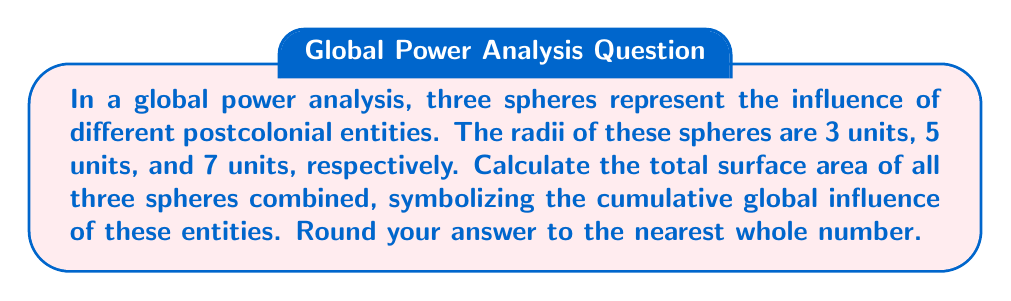Could you help me with this problem? To solve this problem, we'll follow these steps:

1) The formula for the surface area of a sphere is $A = 4\pi r^2$, where $r$ is the radius.

2) Let's calculate the surface area for each sphere:

   Sphere 1 (radius 3): $A_1 = 4\pi (3)^2 = 36\pi$
   Sphere 2 (radius 5): $A_2 = 4\pi (5)^2 = 100\pi$
   Sphere 3 (radius 7): $A_3 = 4\pi (7)^2 = 196\pi$

3) Now, we sum these areas:

   $$A_{total} = A_1 + A_2 + A_3 = 36\pi + 100\pi + 196\pi = 332\pi$$

4) To get a numerical value, we multiply by $\pi \approx 3.14159$:

   $$A_{total} \approx 332 * 3.14159 \approx 1042.99788$$

5) Rounding to the nearest whole number:

   $$A_{total} \approx 1043$$

This result symbolizes the total "surface area" of influence of these postcolonial entities in the global power structure.
Answer: 1043 square units 